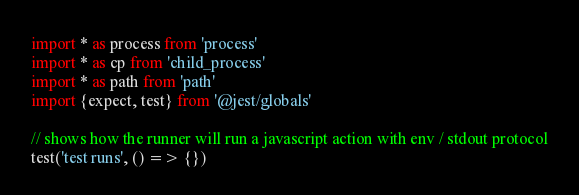<code> <loc_0><loc_0><loc_500><loc_500><_TypeScript_>import * as process from 'process'
import * as cp from 'child_process'
import * as path from 'path'
import {expect, test} from '@jest/globals'

// shows how the runner will run a javascript action with env / stdout protocol
test('test runs', () => {})
</code> 